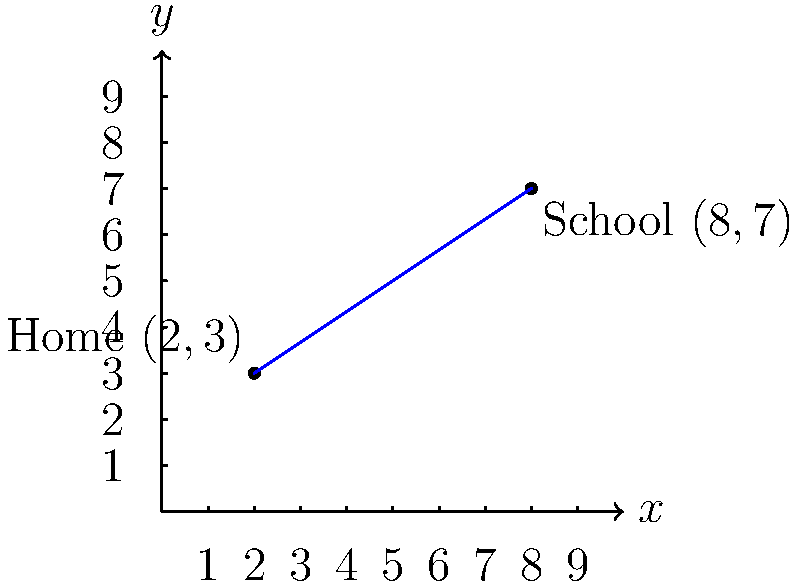Miguel's child walks from home to school every day. On a coordinate grid, their home is located at (2,3) and the school is at (8,7). Calculate the slope of the straight line representing the child's route to school. To find the slope of the line passing through two points, we can use the slope formula:

$$ \text{Slope} = m = \frac{y_2 - y_1}{x_2 - x_1} $$

Where $(x_1, y_1)$ is the first point and $(x_2, y_2)$ is the second point.

Given:
- Home (Point 1): $(x_1, y_1) = (2, 3)$
- School (Point 2): $(x_2, y_2) = (8, 7)$

Let's plug these values into the formula:

$$ m = \frac{y_2 - y_1}{x_2 - x_1} = \frac{7 - 3}{8 - 2} = \frac{4}{6} $$

Simplify the fraction:

$$ m = \frac{4}{6} = \frac{2}{3} $$

Therefore, the slope of the line representing the child's route to school is $\frac{2}{3}$.
Answer: $\frac{2}{3}$ 